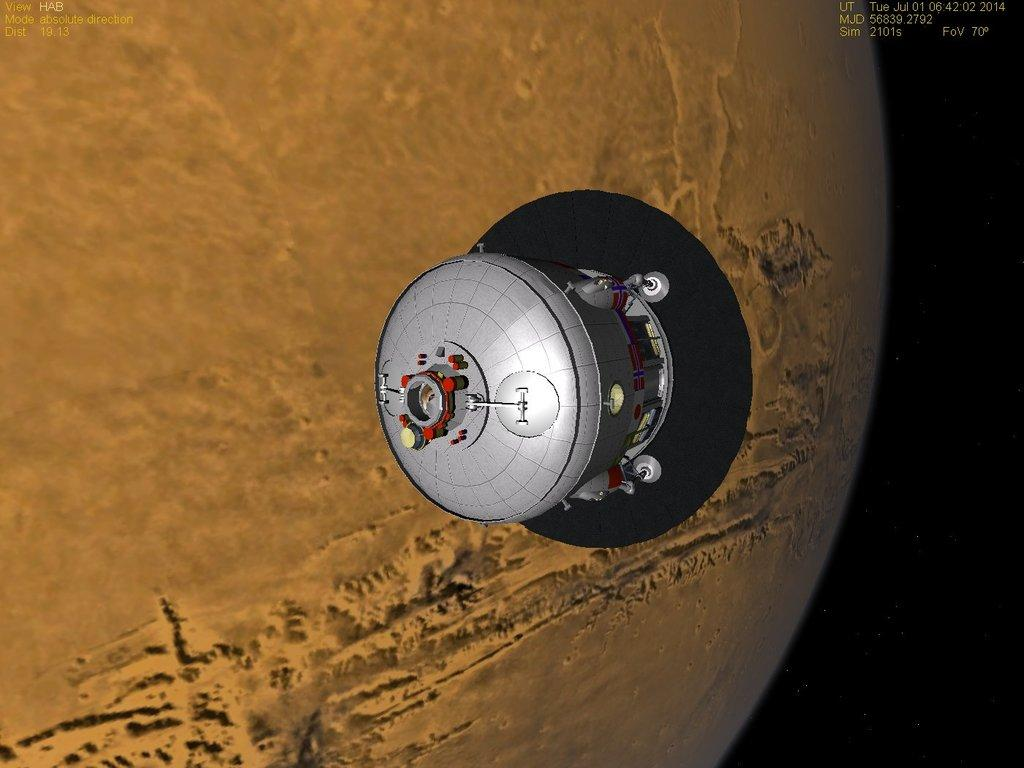What type of image is being described? The image is animated. What can be seen in the image that is related to technology? There is a satellite in the image. What celestial body is depicted in the image? The image depicts a planet. Is there any additional information or branding on the image? Yes, there is a watermark on the image. Where is the setting of the image? The image is set in space. How many bikes are parked on the planet in the image? There are no bikes present in the image; it depicts a planet in space with a satellite. What type of yak can be seen grazing on the planet's surface in the image? There are no yaks present in the image; it depicts a planet in space with a satellite. 